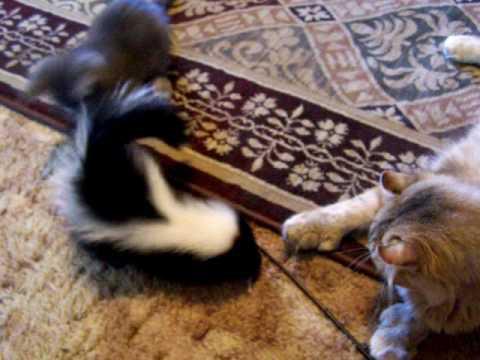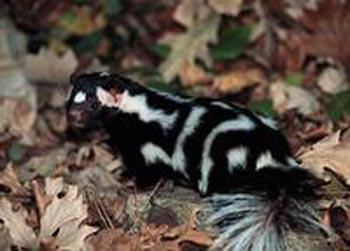The first image is the image on the left, the second image is the image on the right. For the images displayed, is the sentence "There is more than one species of animal." factually correct? Answer yes or no. Yes. The first image is the image on the left, the second image is the image on the right. Considering the images on both sides, is "One image shows a reclining mother cat with a kitten and a skunk in front of it." valid? Answer yes or no. Yes. 